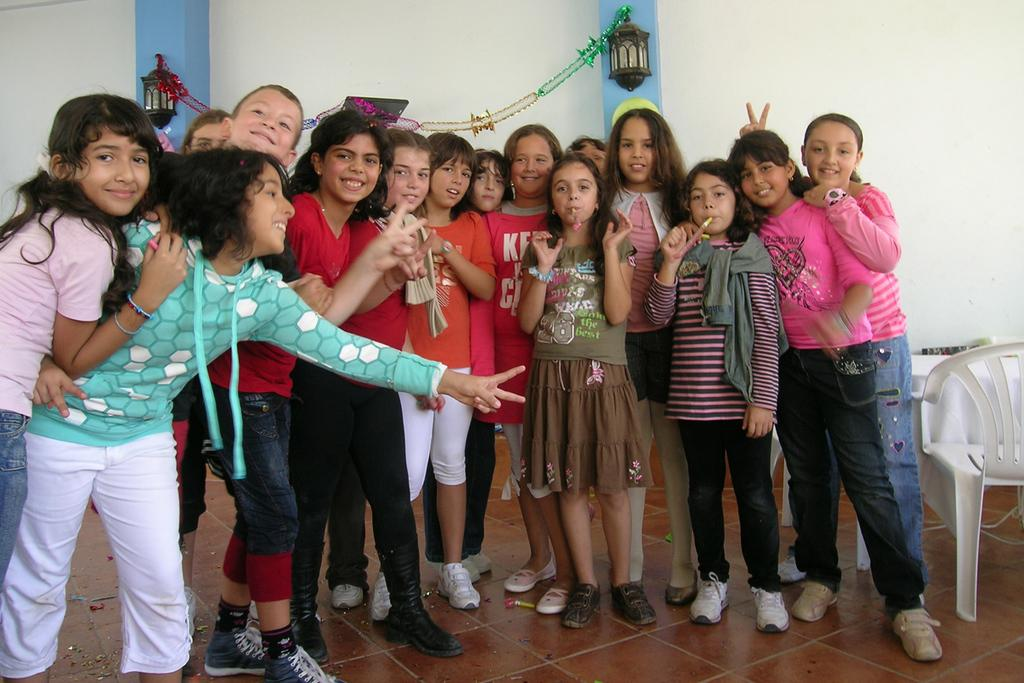What is the main subject of the image? The main subject of the image is kids standing on the floor. What can be seen on the right side of the image? There are chairs on the right side of the image. What is attached to the wall in the image? There are lamps attached to the wall in the image. What is unique about the lamps in the image? Decorative papers are attached to the lamps in the image. What type of pets are visible in the image? There are no pets visible in the image. How many rings can be seen on the kids' fingers in the image? There is no mention of rings or any jewelry in the image. 